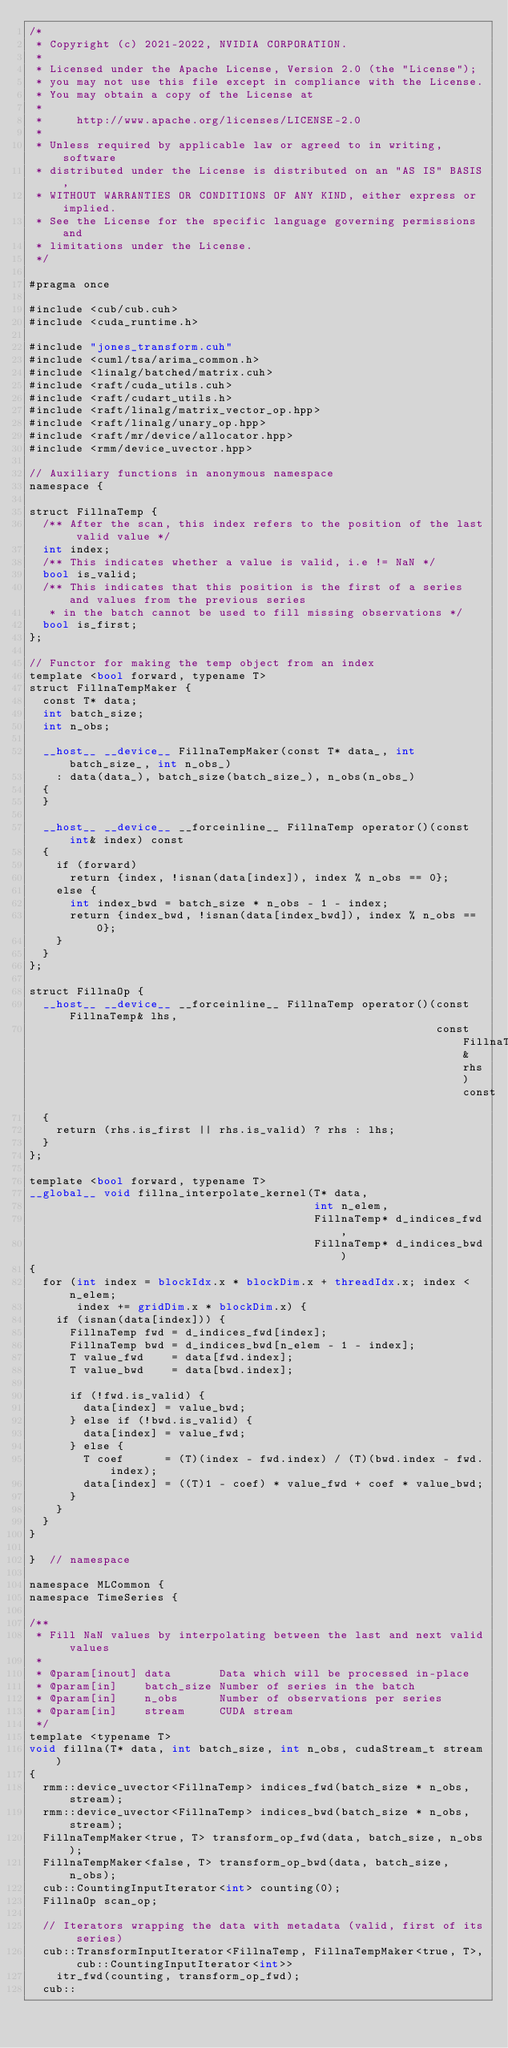<code> <loc_0><loc_0><loc_500><loc_500><_Cuda_>/*
 * Copyright (c) 2021-2022, NVIDIA CORPORATION.
 *
 * Licensed under the Apache License, Version 2.0 (the "License");
 * you may not use this file except in compliance with the License.
 * You may obtain a copy of the License at
 *
 *     http://www.apache.org/licenses/LICENSE-2.0
 *
 * Unless required by applicable law or agreed to in writing, software
 * distributed under the License is distributed on an "AS IS" BASIS,
 * WITHOUT WARRANTIES OR CONDITIONS OF ANY KIND, either express or implied.
 * See the License for the specific language governing permissions and
 * limitations under the License.
 */

#pragma once

#include <cub/cub.cuh>
#include <cuda_runtime.h>

#include "jones_transform.cuh"
#include <cuml/tsa/arima_common.h>
#include <linalg/batched/matrix.cuh>
#include <raft/cuda_utils.cuh>
#include <raft/cudart_utils.h>
#include <raft/linalg/matrix_vector_op.hpp>
#include <raft/linalg/unary_op.hpp>
#include <raft/mr/device/allocator.hpp>
#include <rmm/device_uvector.hpp>

// Auxiliary functions in anonymous namespace
namespace {

struct FillnaTemp {
  /** After the scan, this index refers to the position of the last valid value */
  int index;
  /** This indicates whether a value is valid, i.e != NaN */
  bool is_valid;
  /** This indicates that this position is the first of a series and values from the previous series
   * in the batch cannot be used to fill missing observations */
  bool is_first;
};

// Functor for making the temp object from an index
template <bool forward, typename T>
struct FillnaTempMaker {
  const T* data;
  int batch_size;
  int n_obs;

  __host__ __device__ FillnaTempMaker(const T* data_, int batch_size_, int n_obs_)
    : data(data_), batch_size(batch_size_), n_obs(n_obs_)
  {
  }

  __host__ __device__ __forceinline__ FillnaTemp operator()(const int& index) const
  {
    if (forward)
      return {index, !isnan(data[index]), index % n_obs == 0};
    else {
      int index_bwd = batch_size * n_obs - 1 - index;
      return {index_bwd, !isnan(data[index_bwd]), index % n_obs == 0};
    }
  }
};

struct FillnaOp {
  __host__ __device__ __forceinline__ FillnaTemp operator()(const FillnaTemp& lhs,
                                                            const FillnaTemp& rhs) const
  {
    return (rhs.is_first || rhs.is_valid) ? rhs : lhs;
  }
};

template <bool forward, typename T>
__global__ void fillna_interpolate_kernel(T* data,
                                          int n_elem,
                                          FillnaTemp* d_indices_fwd,
                                          FillnaTemp* d_indices_bwd)
{
  for (int index = blockIdx.x * blockDim.x + threadIdx.x; index < n_elem;
       index += gridDim.x * blockDim.x) {
    if (isnan(data[index])) {
      FillnaTemp fwd = d_indices_fwd[index];
      FillnaTemp bwd = d_indices_bwd[n_elem - 1 - index];
      T value_fwd    = data[fwd.index];
      T value_bwd    = data[bwd.index];

      if (!fwd.is_valid) {
        data[index] = value_bwd;
      } else if (!bwd.is_valid) {
        data[index] = value_fwd;
      } else {
        T coef      = (T)(index - fwd.index) / (T)(bwd.index - fwd.index);
        data[index] = ((T)1 - coef) * value_fwd + coef * value_bwd;
      }
    }
  }
}

}  // namespace

namespace MLCommon {
namespace TimeSeries {

/**
 * Fill NaN values by interpolating between the last and next valid values
 *
 * @param[inout] data       Data which will be processed in-place
 * @param[in]    batch_size Number of series in the batch
 * @param[in]    n_obs      Number of observations per series
 * @param[in]    stream     CUDA stream
 */
template <typename T>
void fillna(T* data, int batch_size, int n_obs, cudaStream_t stream)
{
  rmm::device_uvector<FillnaTemp> indices_fwd(batch_size * n_obs, stream);
  rmm::device_uvector<FillnaTemp> indices_bwd(batch_size * n_obs, stream);
  FillnaTempMaker<true, T> transform_op_fwd(data, batch_size, n_obs);
  FillnaTempMaker<false, T> transform_op_bwd(data, batch_size, n_obs);
  cub::CountingInputIterator<int> counting(0);
  FillnaOp scan_op;

  // Iterators wrapping the data with metadata (valid, first of its series)
  cub::TransformInputIterator<FillnaTemp, FillnaTempMaker<true, T>, cub::CountingInputIterator<int>>
    itr_fwd(counting, transform_op_fwd);
  cub::</code> 